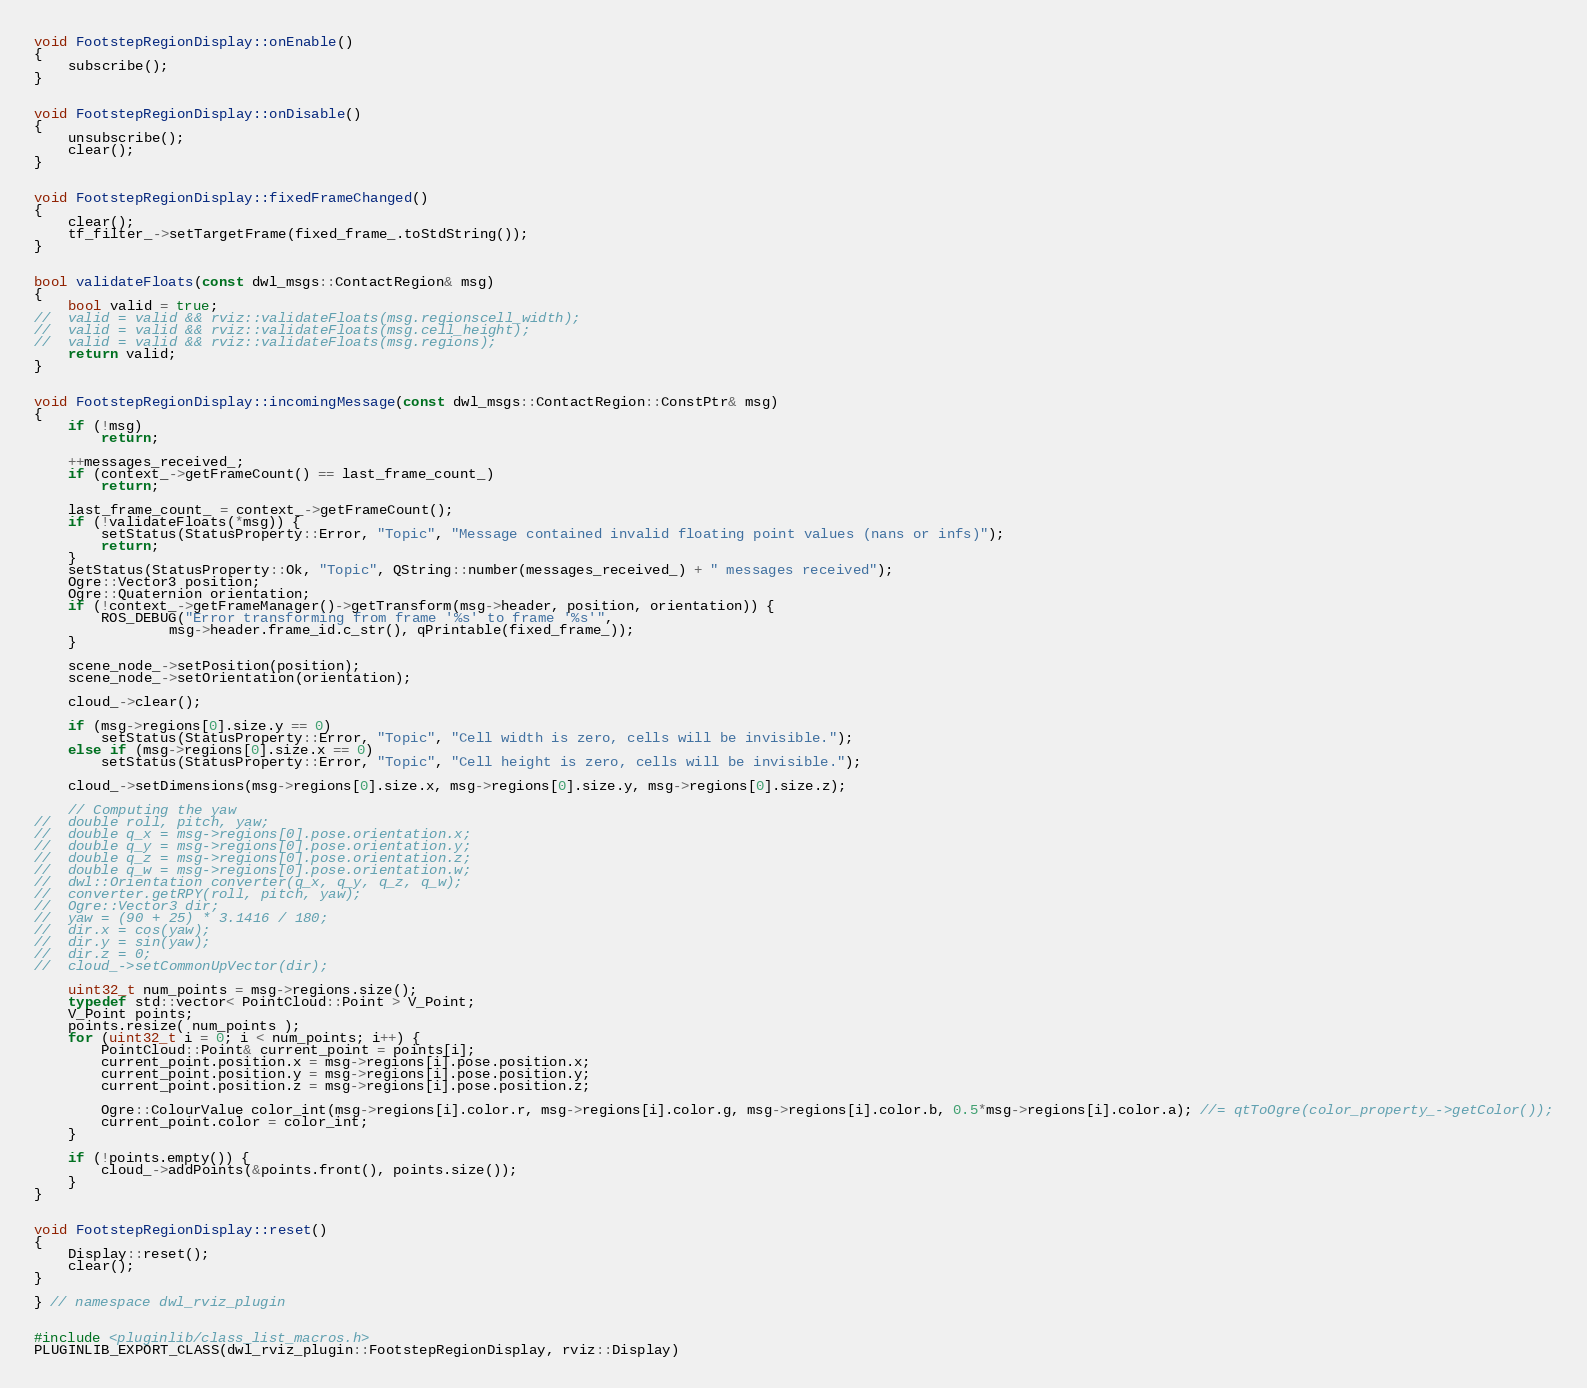<code> <loc_0><loc_0><loc_500><loc_500><_C++_>

void FootstepRegionDisplay::onEnable()
{
	subscribe();
}


void FootstepRegionDisplay::onDisable()
{
	unsubscribe();
	clear();
}


void FootstepRegionDisplay::fixedFrameChanged()
{
	clear();
	tf_filter_->setTargetFrame(fixed_frame_.toStdString());
}


bool validateFloats(const dwl_msgs::ContactRegion& msg)
{
	bool valid = true;
//	valid = valid && rviz::validateFloats(msg.regionscell_width);
//	valid = valid && rviz::validateFloats(msg.cell_height);
//	valid = valid && rviz::validateFloats(msg.regions);
	return valid;
}


void FootstepRegionDisplay::incomingMessage(const dwl_msgs::ContactRegion::ConstPtr& msg)
{
	if (!msg)
		return;

	++messages_received_;
	if (context_->getFrameCount() == last_frame_count_)
		return;

	last_frame_count_ = context_->getFrameCount();
	if (!validateFloats(*msg)) {
		setStatus(StatusProperty::Error, "Topic", "Message contained invalid floating point values (nans or infs)");
		return;
	}
	setStatus(StatusProperty::Ok, "Topic", QString::number(messages_received_) + " messages received");
	Ogre::Vector3 position;
	Ogre::Quaternion orientation;
	if (!context_->getFrameManager()->getTransform(msg->header, position, orientation)) {
		ROS_DEBUG("Error transforming from frame '%s' to frame '%s'",
				msg->header.frame_id.c_str(), qPrintable(fixed_frame_));
	}

	scene_node_->setPosition(position);
	scene_node_->setOrientation(orientation);

	cloud_->clear();

	if (msg->regions[0].size.y == 0)
		setStatus(StatusProperty::Error, "Topic", "Cell width is zero, cells will be invisible.");
	else if (msg->regions[0].size.x == 0)
		setStatus(StatusProperty::Error, "Topic", "Cell height is zero, cells will be invisible.");

	cloud_->setDimensions(msg->regions[0].size.x, msg->regions[0].size.y, msg->regions[0].size.z);

	// Computing the yaw
//	double roll, pitch, yaw;
//	double q_x = msg->regions[0].pose.orientation.x;
//	double q_y = msg->regions[0].pose.orientation.y;
//	double q_z = msg->regions[0].pose.orientation.z;
//	double q_w = msg->regions[0].pose.orientation.w;
//	dwl::Orientation converter(q_x, q_y, q_z, q_w);
//	converter.getRPY(roll, pitch, yaw);
//	Ogre::Vector3 dir;
//	yaw = (90 + 25) * 3.1416 / 180;
//	dir.x = cos(yaw);
//	dir.y = sin(yaw);
//	dir.z = 0;
//	cloud_->setCommonUpVector(dir);

	uint32_t num_points = msg->regions.size();
	typedef std::vector< PointCloud::Point > V_Point;
	V_Point points;
	points.resize( num_points );
	for (uint32_t i = 0; i < num_points; i++) {
		PointCloud::Point& current_point = points[i];
		current_point.position.x = msg->regions[i].pose.position.x;
		current_point.position.y = msg->regions[i].pose.position.y;
		current_point.position.z = msg->regions[i].pose.position.z;

		Ogre::ColourValue color_int(msg->regions[i].color.r, msg->regions[i].color.g, msg->regions[i].color.b, 0.5*msg->regions[i].color.a); //= qtToOgre(color_property_->getColor());
		current_point.color = color_int;
	}

	if (!points.empty()) {
		cloud_->addPoints(&points.front(), points.size());
	}
}


void FootstepRegionDisplay::reset()
{
	Display::reset();
	clear();
}

} // namespace dwl_rviz_plugin


#include <pluginlib/class_list_macros.h>
PLUGINLIB_EXPORT_CLASS(dwl_rviz_plugin::FootstepRegionDisplay, rviz::Display)
</code> 